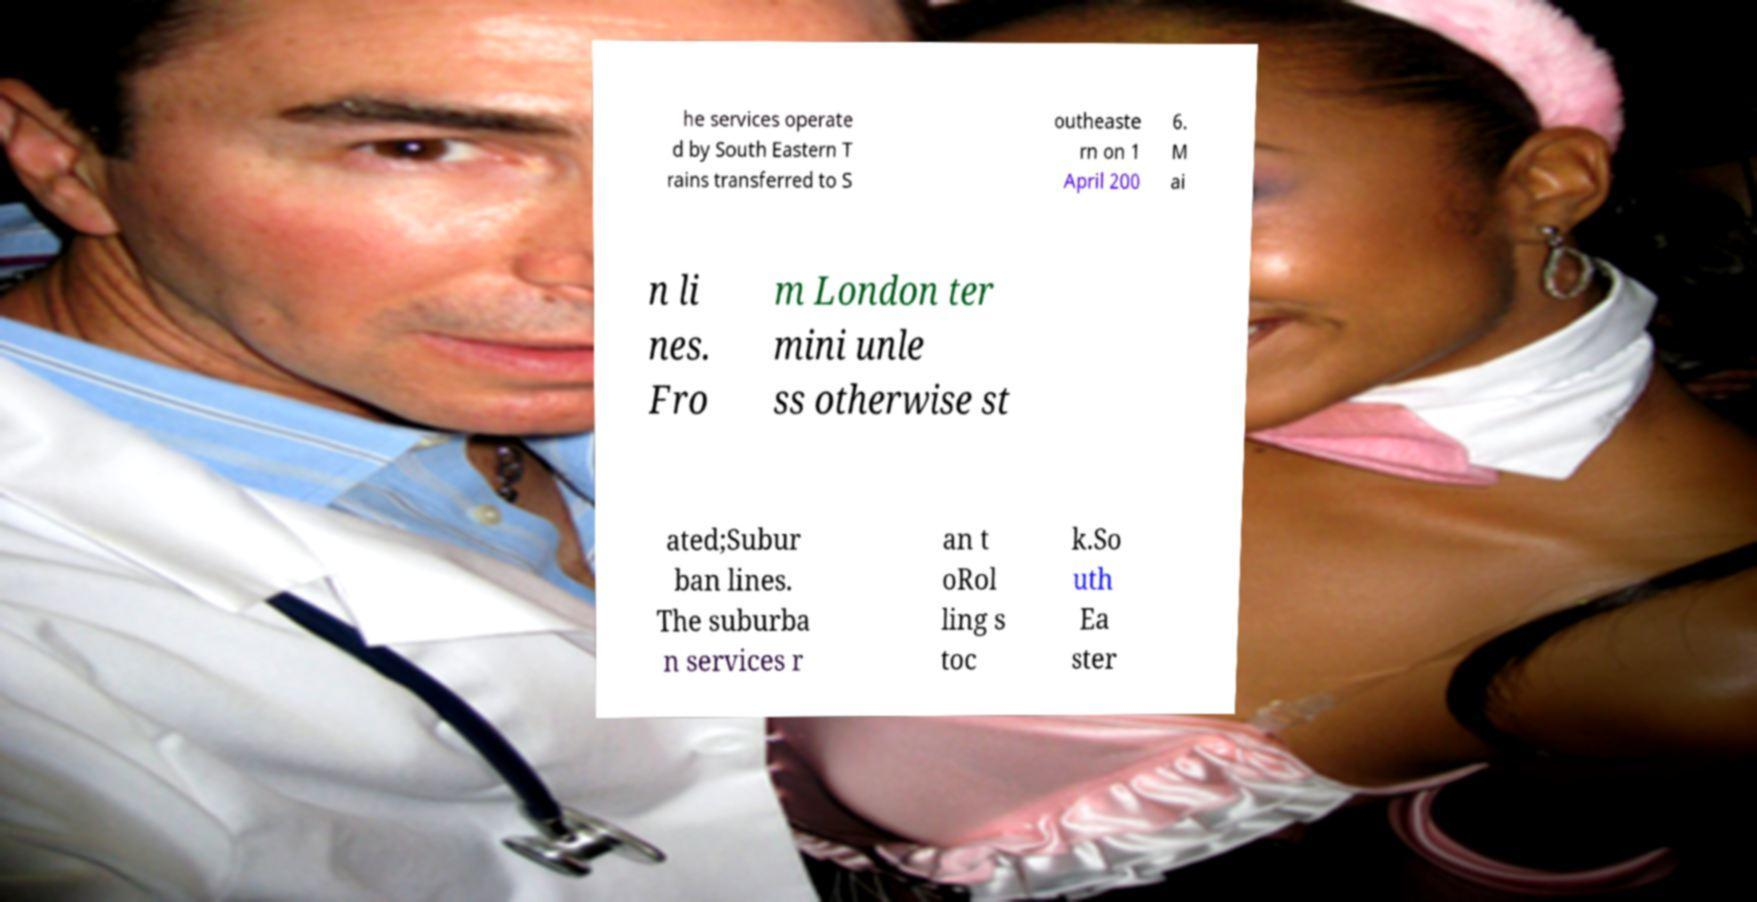Please identify and transcribe the text found in this image. he services operate d by South Eastern T rains transferred to S outheaste rn on 1 April 200 6. M ai n li nes. Fro m London ter mini unle ss otherwise st ated;Subur ban lines. The suburba n services r an t oRol ling s toc k.So uth Ea ster 